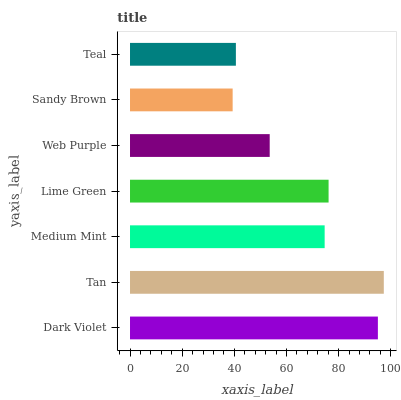Is Sandy Brown the minimum?
Answer yes or no. Yes. Is Tan the maximum?
Answer yes or no. Yes. Is Medium Mint the minimum?
Answer yes or no. No. Is Medium Mint the maximum?
Answer yes or no. No. Is Tan greater than Medium Mint?
Answer yes or no. Yes. Is Medium Mint less than Tan?
Answer yes or no. Yes. Is Medium Mint greater than Tan?
Answer yes or no. No. Is Tan less than Medium Mint?
Answer yes or no. No. Is Medium Mint the high median?
Answer yes or no. Yes. Is Medium Mint the low median?
Answer yes or no. Yes. Is Lime Green the high median?
Answer yes or no. No. Is Dark Violet the low median?
Answer yes or no. No. 